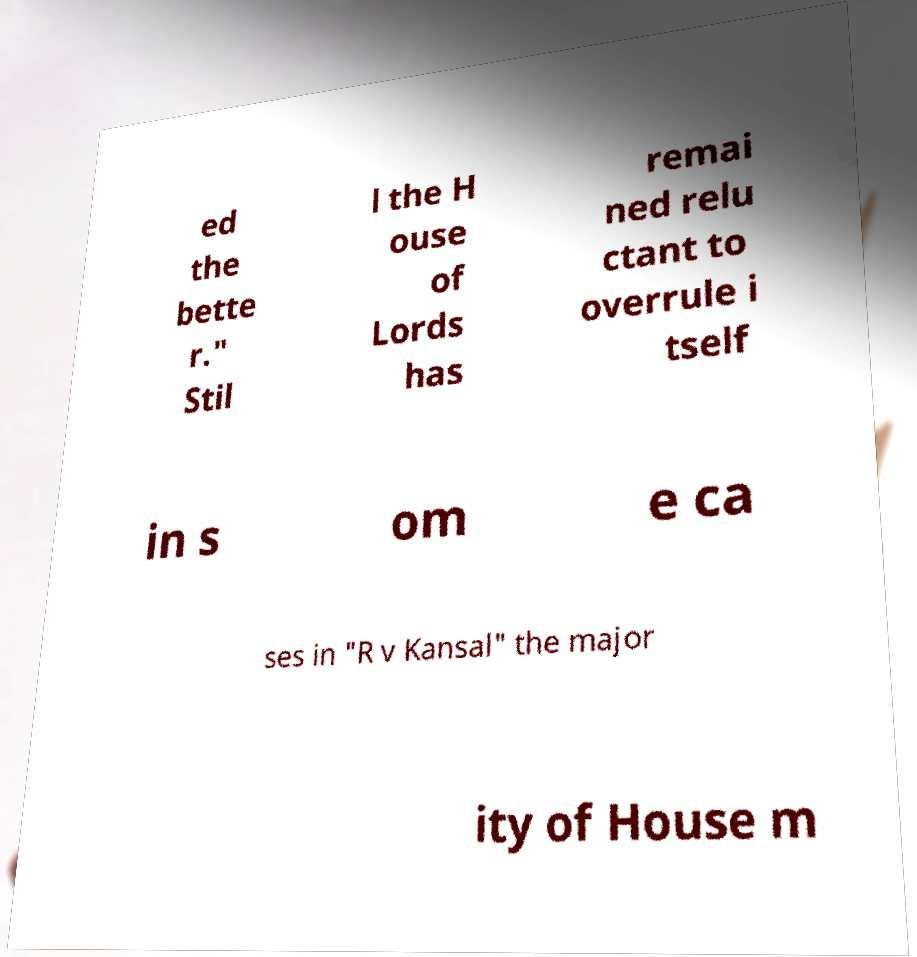Can you read and provide the text displayed in the image?This photo seems to have some interesting text. Can you extract and type it out for me? ed the bette r." Stil l the H ouse of Lords has remai ned relu ctant to overrule i tself in s om e ca ses in "R v Kansal" the major ity of House m 